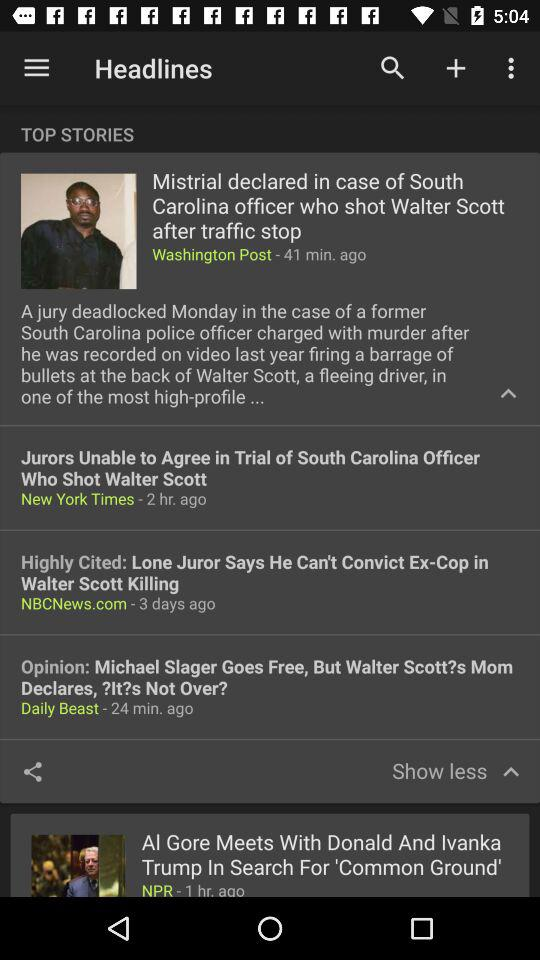What is the post published by the Daily Beast? The post is "Opinion: Michael Slager Goes Free, But Walter Scott?s Mom Declares,?It?s Not Over?". 